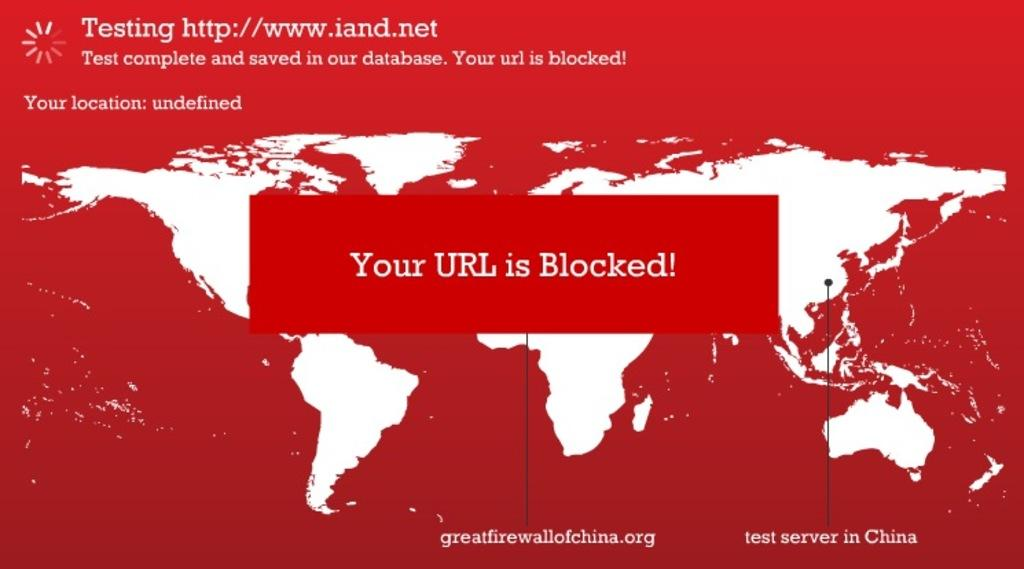Provide a one-sentence caption for the provided image. a red background with a URL blocked message. 